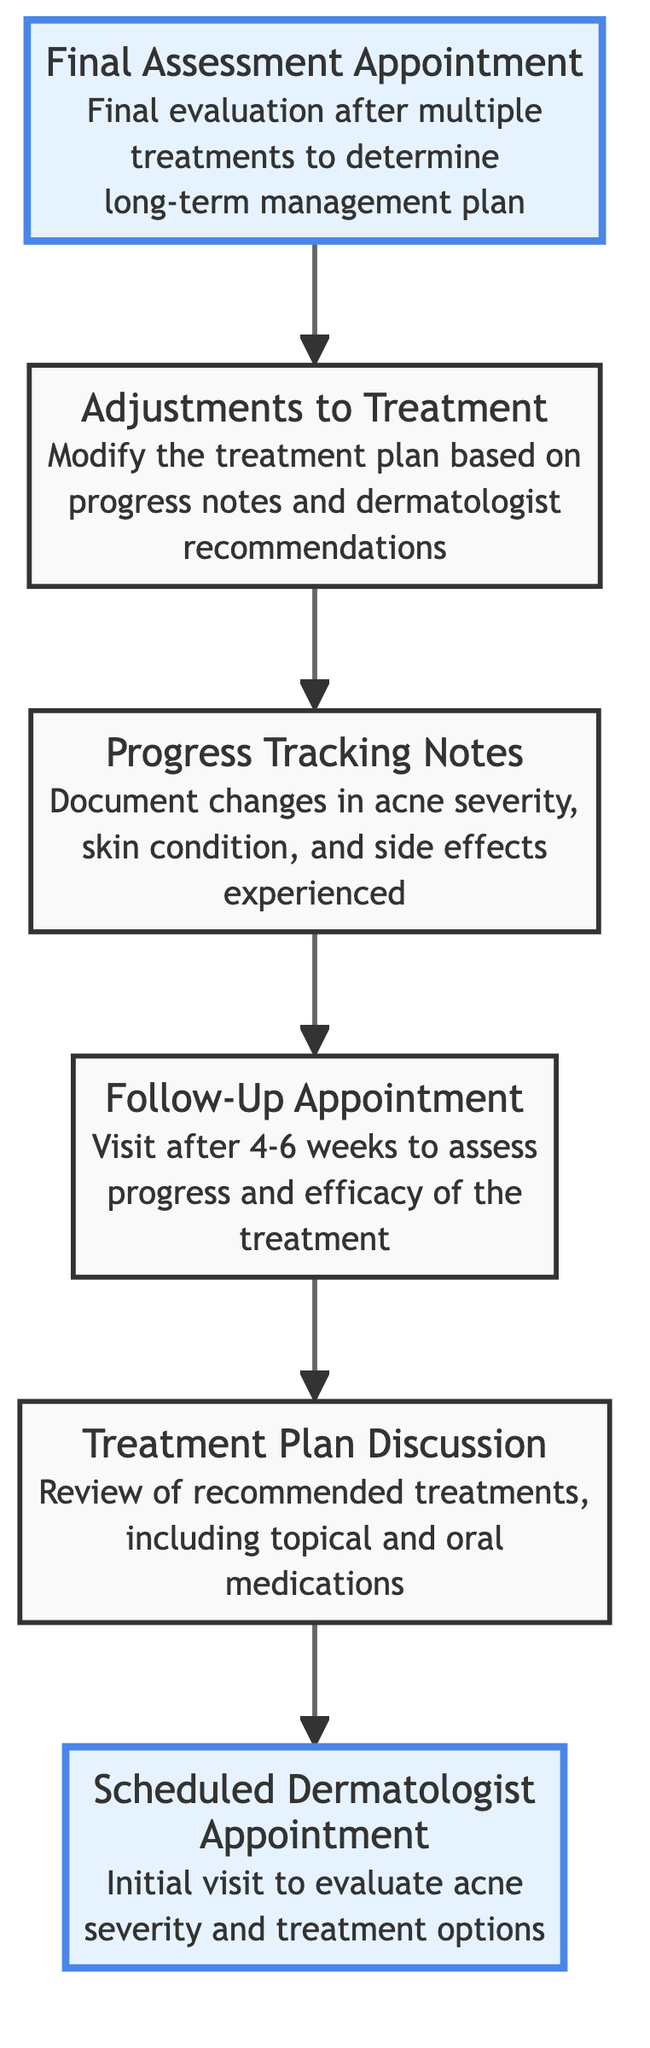What is the final appointment in the flow chart? The last node in the chart is labeled "Final Assessment Appointment," which indicates it is the final evaluation after multiple treatments.
Answer: Final Assessment Appointment How many nodes are in the diagram? Counting the individual elements listed, there are a total of six nodes in the diagram, each representing a step in the dermatology treatment process.
Answer: 6 What is the purpose of the Follow-Up Appointment? The description of the "Follow-Up Appointment" states that its purpose is to assess progress and efficacy of the treatment after 4-6 weeks, indicating it is crucial for evaluating treatment results.
Answer: Assess progress and efficacy Which node directly follows the Progress Tracking Notes? Looking through the flow chart, the "Adjustments to Treatment" node immediately follows the "Progress Tracking Notes" node, indicating it comes next in the process.
Answer: Adjustments to Treatment What is the relationship between the Treatment Plan Discussion and the Scheduled Dermatologist Appointment? The "Treatment Plan Discussion" follows the "Scheduled Dermatologist Appointment" in the flow chart, showing that it is the next step after the initial evaluation visit.
Answer: Treatment Plan Discussion What type of changes are documented in Progress Tracking Notes? The "Progress Tracking Notes" specifically mention documenting changes in acne severity, skin condition, and side effects experienced, which are vital aspects of monitoring treatment effects.
Answer: Changes in acne severity, skin condition, and side effects How does the diagram demonstrate the flow from treatment planning to follow-up? The flow chart illustrates that the "Scheduled Dermatologist Appointment" leads to the "Treatment Plan Discussion," which then progresses to "Follow-Up Appointment," indicating an order of evaluation and treatment adjustment.
Answer: Sequential flow from planning to follow-up Which step involves modifying the treatment plan? The step labeled "Adjustments to Treatment" outlines the process of modifying the treatment plan based on progress notes and dermatologist recommendations, indicating when changes are made.
Answer: Adjustments to Treatment What is the initial step in the flow of appointments? The first step in the flow is the "Scheduled Dermatologist Appointment," which serves as the starting point for evaluating acne and determining treatment options.
Answer: Scheduled Dermatologist Appointment 